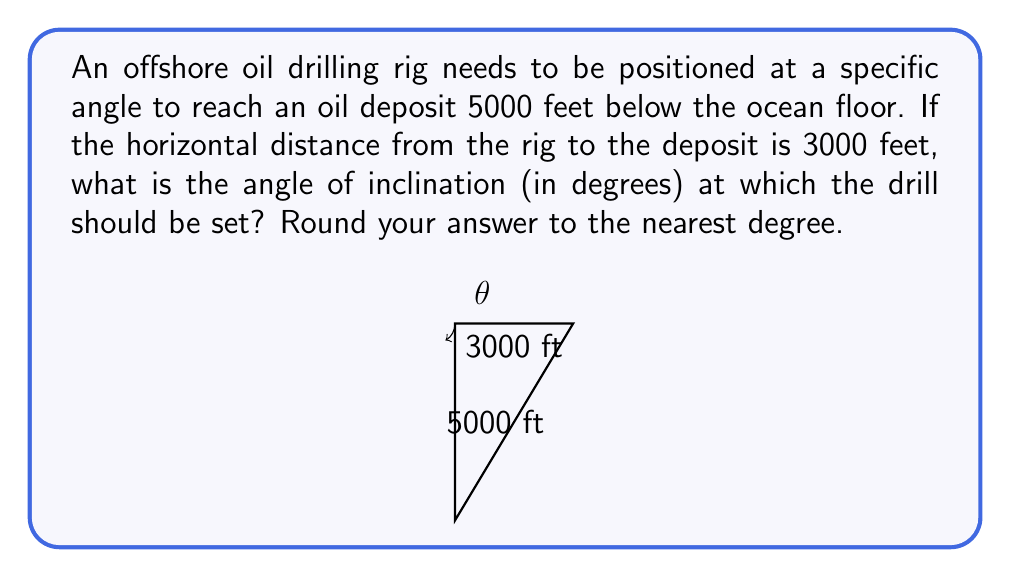Can you solve this math problem? Let's approach this step-by-step using trigonometry:

1) We can visualize this as a right triangle, where:
   - The vertical depth (5000 feet) is the opposite side
   - The horizontal distance (3000 feet) is the adjacent side
   - The angle we're looking for is the angle of inclination from the horizontal

2) In this scenario, we need to use the tangent function, as it relates the opposite and adjacent sides:

   $$\tan(\theta) = \frac{\text{opposite}}{\text{adjacent}}$$

3) Plugging in our values:

   $$\tan(\theta) = \frac{5000}{3000}$$

4) Simplify:

   $$\tan(\theta) = \frac{5}{3}$$

5) To find $\theta$, we need to use the inverse tangent (arctan or $\tan^{-1}$):

   $$\theta = \tan^{-1}\left(\frac{5}{3}\right)$$

6) Using a calculator or computer:

   $$\theta \approx 59.04 \text{ degrees}$$

7) Rounding to the nearest degree:

   $$\theta \approx 59 \text{ degrees}$$

Thus, the drill should be set at an angle of approximately 59 degrees from the horizontal.
Answer: $59^\circ$ 